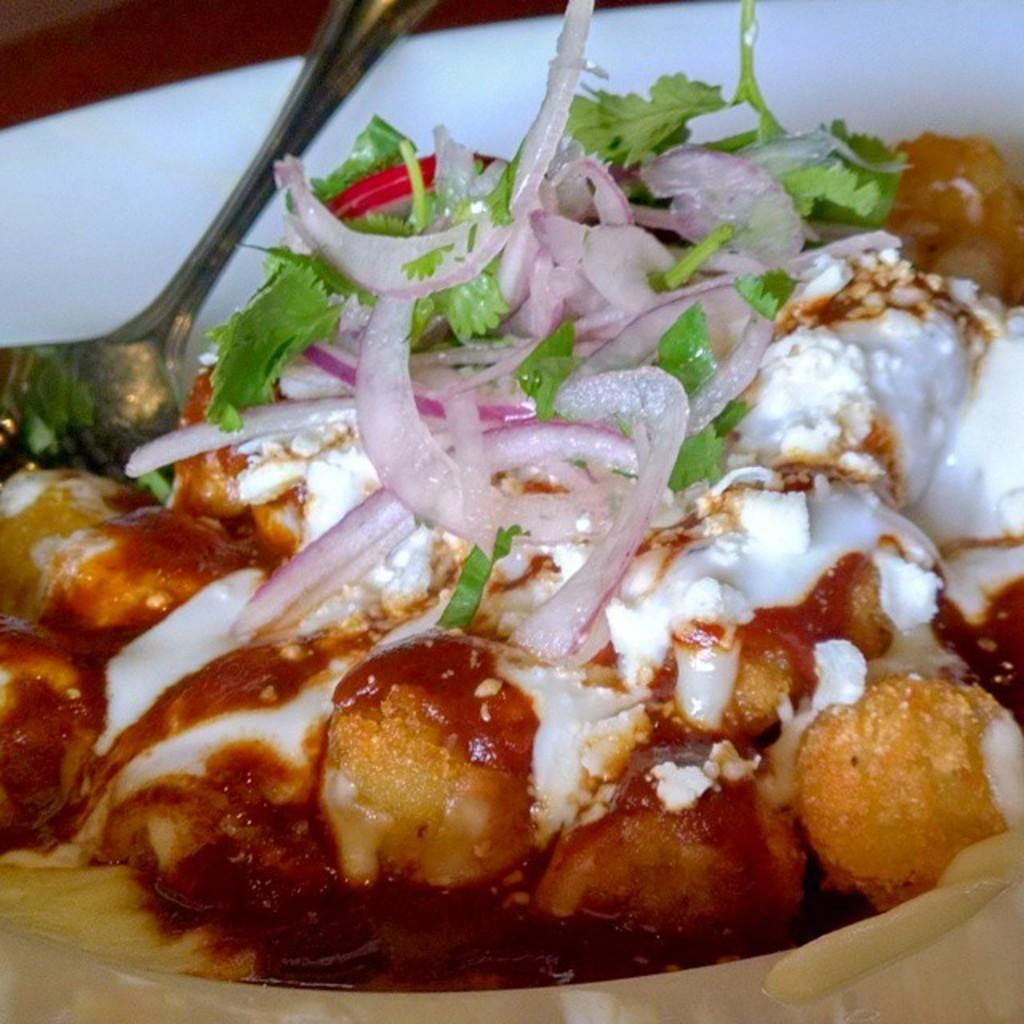What is on the plate in the image? There is a white plate in the image. What utensil is present in the image? There is a spoon in the image. What is the main subject of the image? The main subject of the image is food. How does the behavior of the food compare to that of a cat in the image? There is no cat present in the image, so it is not possible to compare the behavior of the food to that of a cat. 